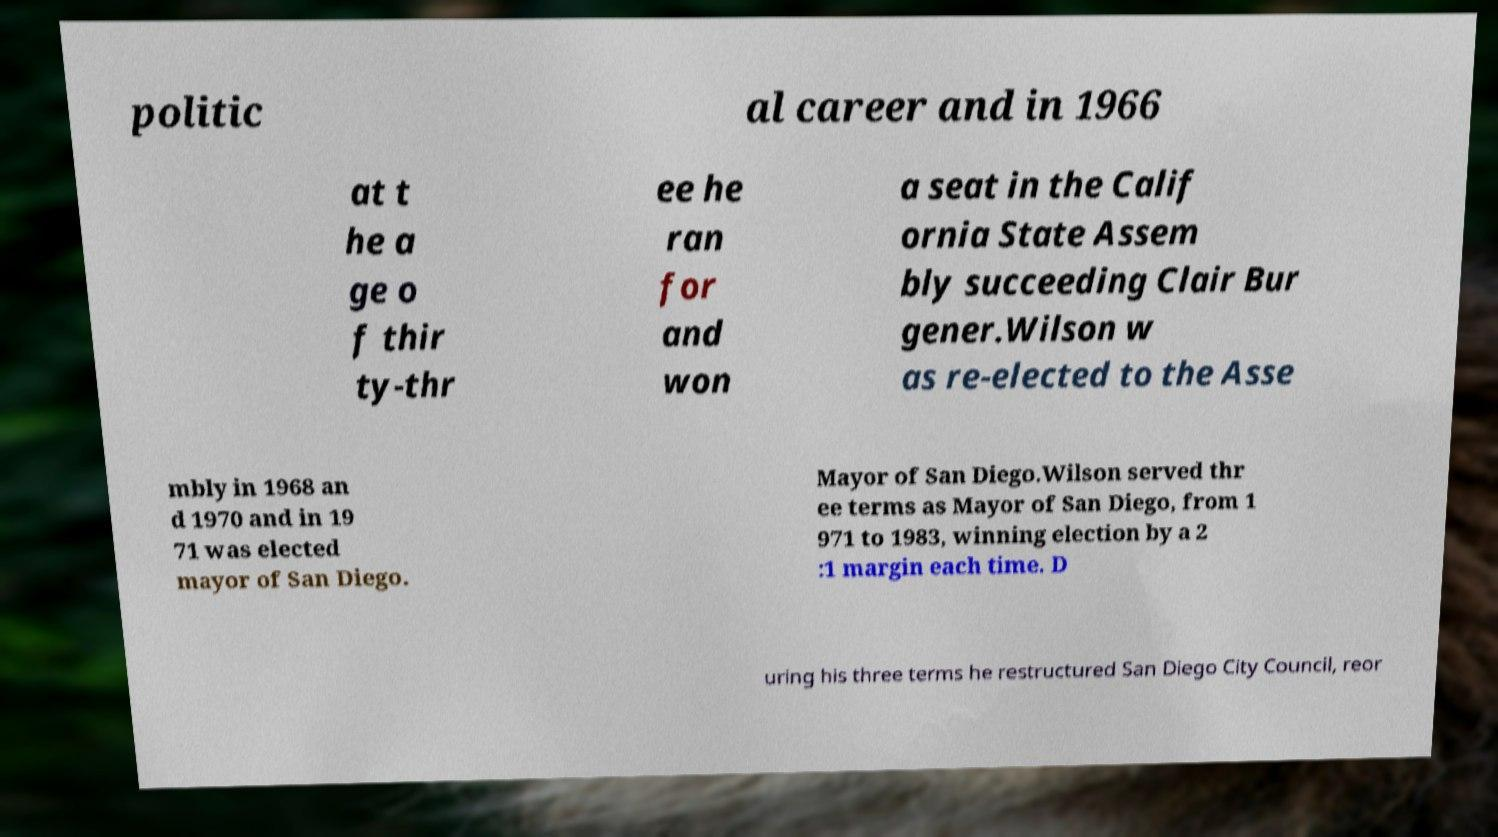Could you assist in decoding the text presented in this image and type it out clearly? politic al career and in 1966 at t he a ge o f thir ty-thr ee he ran for and won a seat in the Calif ornia State Assem bly succeeding Clair Bur gener.Wilson w as re-elected to the Asse mbly in 1968 an d 1970 and in 19 71 was elected mayor of San Diego. Mayor of San Diego.Wilson served thr ee terms as Mayor of San Diego, from 1 971 to 1983, winning election by a 2 :1 margin each time. D uring his three terms he restructured San Diego City Council, reor 